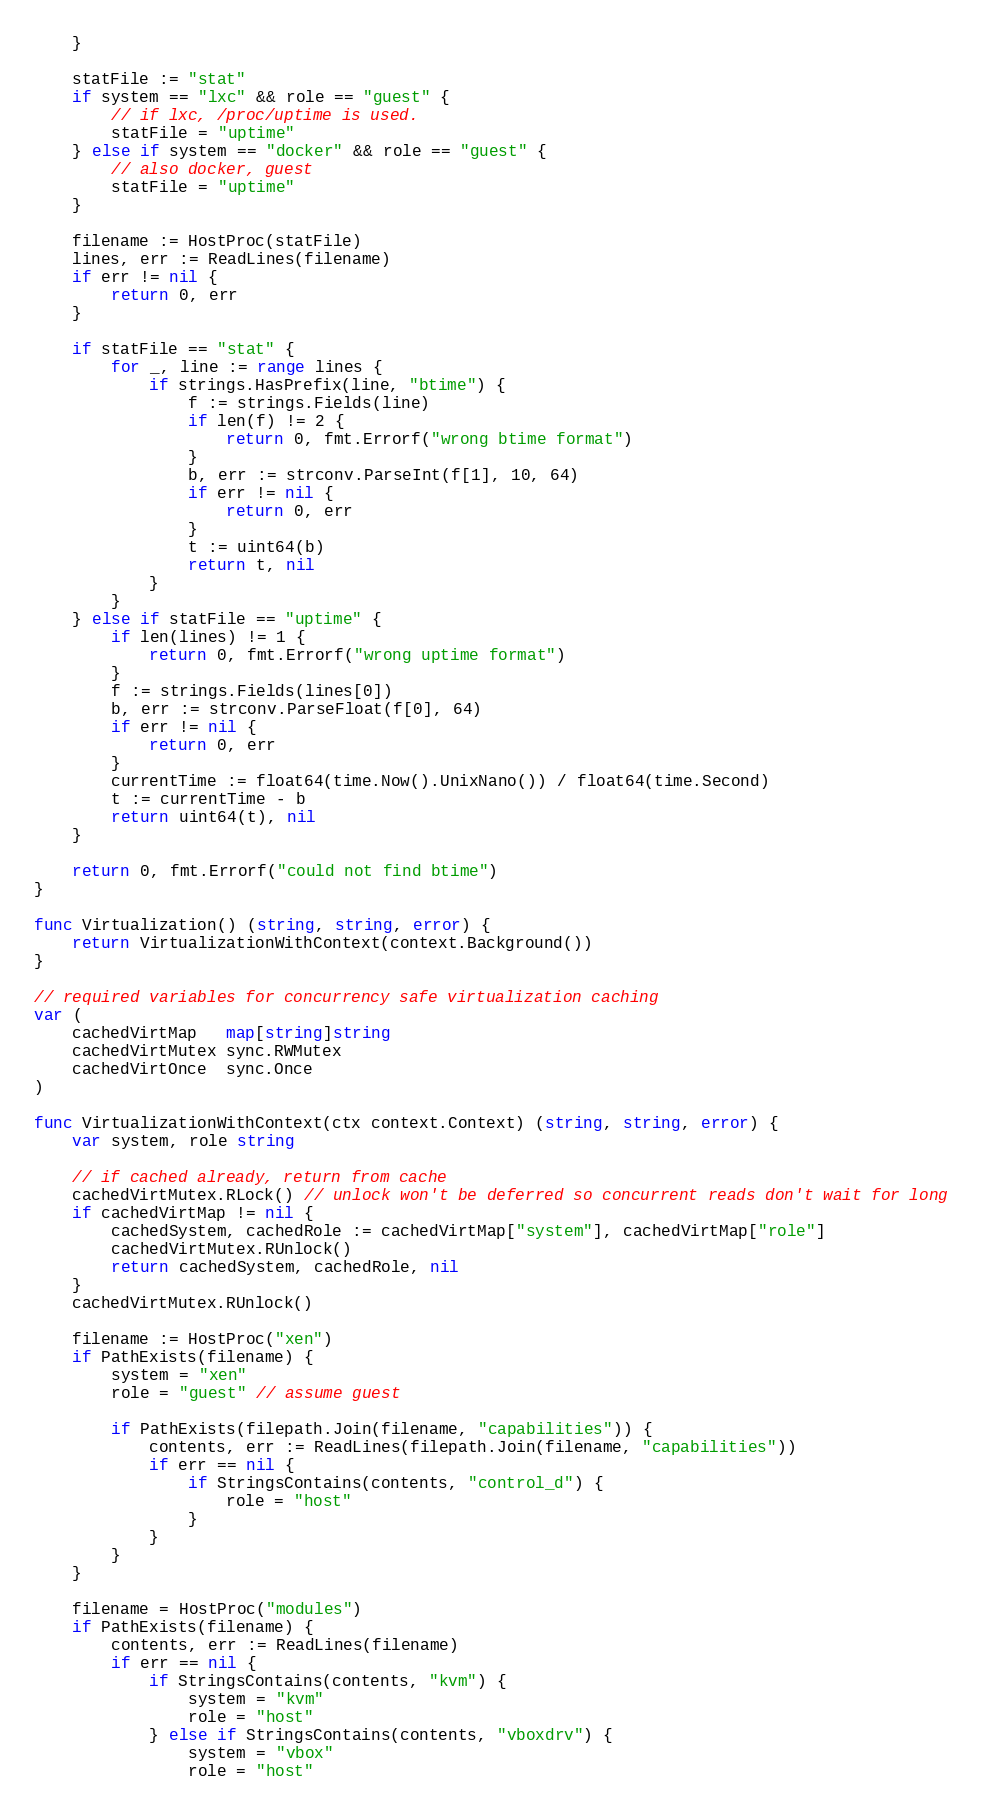Convert code to text. <code><loc_0><loc_0><loc_500><loc_500><_Go_>	}

	statFile := "stat"
	if system == "lxc" && role == "guest" {
		// if lxc, /proc/uptime is used.
		statFile = "uptime"
	} else if system == "docker" && role == "guest" {
		// also docker, guest
		statFile = "uptime"
	}

	filename := HostProc(statFile)
	lines, err := ReadLines(filename)
	if err != nil {
		return 0, err
	}

	if statFile == "stat" {
		for _, line := range lines {
			if strings.HasPrefix(line, "btime") {
				f := strings.Fields(line)
				if len(f) != 2 {
					return 0, fmt.Errorf("wrong btime format")
				}
				b, err := strconv.ParseInt(f[1], 10, 64)
				if err != nil {
					return 0, err
				}
				t := uint64(b)
				return t, nil
			}
		}
	} else if statFile == "uptime" {
		if len(lines) != 1 {
			return 0, fmt.Errorf("wrong uptime format")
		}
		f := strings.Fields(lines[0])
		b, err := strconv.ParseFloat(f[0], 64)
		if err != nil {
			return 0, err
		}
		currentTime := float64(time.Now().UnixNano()) / float64(time.Second)
		t := currentTime - b
		return uint64(t), nil
	}

	return 0, fmt.Errorf("could not find btime")
}

func Virtualization() (string, string, error) {
	return VirtualizationWithContext(context.Background())
}

// required variables for concurrency safe virtualization caching
var (
	cachedVirtMap   map[string]string
	cachedVirtMutex sync.RWMutex
	cachedVirtOnce  sync.Once
)

func VirtualizationWithContext(ctx context.Context) (string, string, error) {
	var system, role string

	// if cached already, return from cache
	cachedVirtMutex.RLock() // unlock won't be deferred so concurrent reads don't wait for long
	if cachedVirtMap != nil {
		cachedSystem, cachedRole := cachedVirtMap["system"], cachedVirtMap["role"]
		cachedVirtMutex.RUnlock()
		return cachedSystem, cachedRole, nil
	}
	cachedVirtMutex.RUnlock()

	filename := HostProc("xen")
	if PathExists(filename) {
		system = "xen"
		role = "guest" // assume guest

		if PathExists(filepath.Join(filename, "capabilities")) {
			contents, err := ReadLines(filepath.Join(filename, "capabilities"))
			if err == nil {
				if StringsContains(contents, "control_d") {
					role = "host"
				}
			}
		}
	}

	filename = HostProc("modules")
	if PathExists(filename) {
		contents, err := ReadLines(filename)
		if err == nil {
			if StringsContains(contents, "kvm") {
				system = "kvm"
				role = "host"
			} else if StringsContains(contents, "vboxdrv") {
				system = "vbox"
				role = "host"</code> 